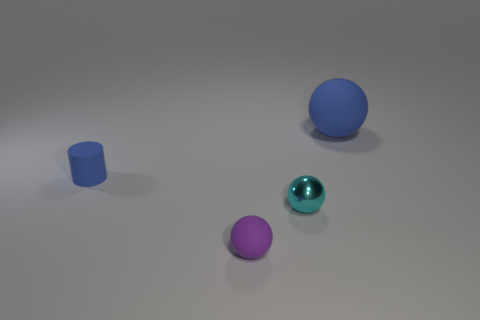Subtract all small purple spheres. How many spheres are left? 2 Add 1 large balls. How many objects exist? 5 Subtract 1 balls. How many balls are left? 2 Add 1 blue cylinders. How many blue cylinders exist? 2 Subtract 1 blue cylinders. How many objects are left? 3 Subtract all spheres. How many objects are left? 1 Subtract all purple cylinders. Subtract all blue blocks. How many cylinders are left? 1 Subtract all gray cylinders. How many cyan balls are left? 1 Subtract all large yellow cubes. Subtract all cyan metal spheres. How many objects are left? 3 Add 2 small cyan metallic objects. How many small cyan metallic objects are left? 3 